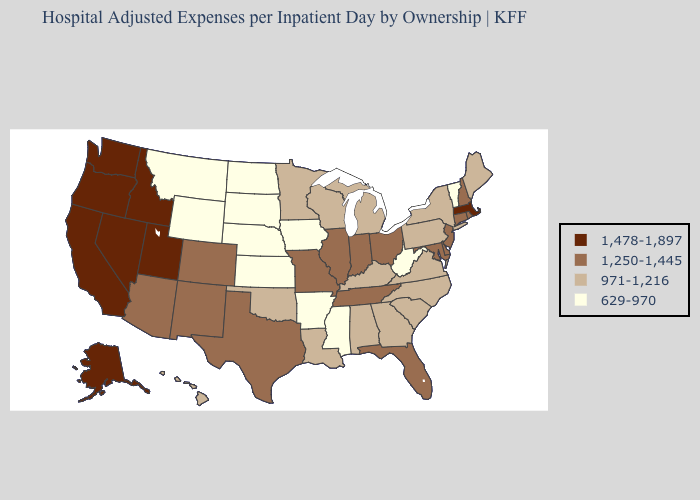Does Rhode Island have the highest value in the Northeast?
Answer briefly. No. Which states have the lowest value in the South?
Concise answer only. Arkansas, Mississippi, West Virginia. Does South Dakota have the lowest value in the USA?
Give a very brief answer. Yes. Name the states that have a value in the range 1,250-1,445?
Write a very short answer. Arizona, Colorado, Connecticut, Delaware, Florida, Illinois, Indiana, Maryland, Missouri, New Hampshire, New Jersey, New Mexico, Ohio, Rhode Island, Tennessee, Texas. Which states have the highest value in the USA?
Give a very brief answer. Alaska, California, Idaho, Massachusetts, Nevada, Oregon, Utah, Washington. What is the highest value in states that border Louisiana?
Concise answer only. 1,250-1,445. What is the value of Indiana?
Give a very brief answer. 1,250-1,445. What is the lowest value in the MidWest?
Give a very brief answer. 629-970. What is the value of New Jersey?
Quick response, please. 1,250-1,445. How many symbols are there in the legend?
Short answer required. 4. What is the value of Colorado?
Quick response, please. 1,250-1,445. How many symbols are there in the legend?
Answer briefly. 4. Which states hav the highest value in the MidWest?
Short answer required. Illinois, Indiana, Missouri, Ohio. 